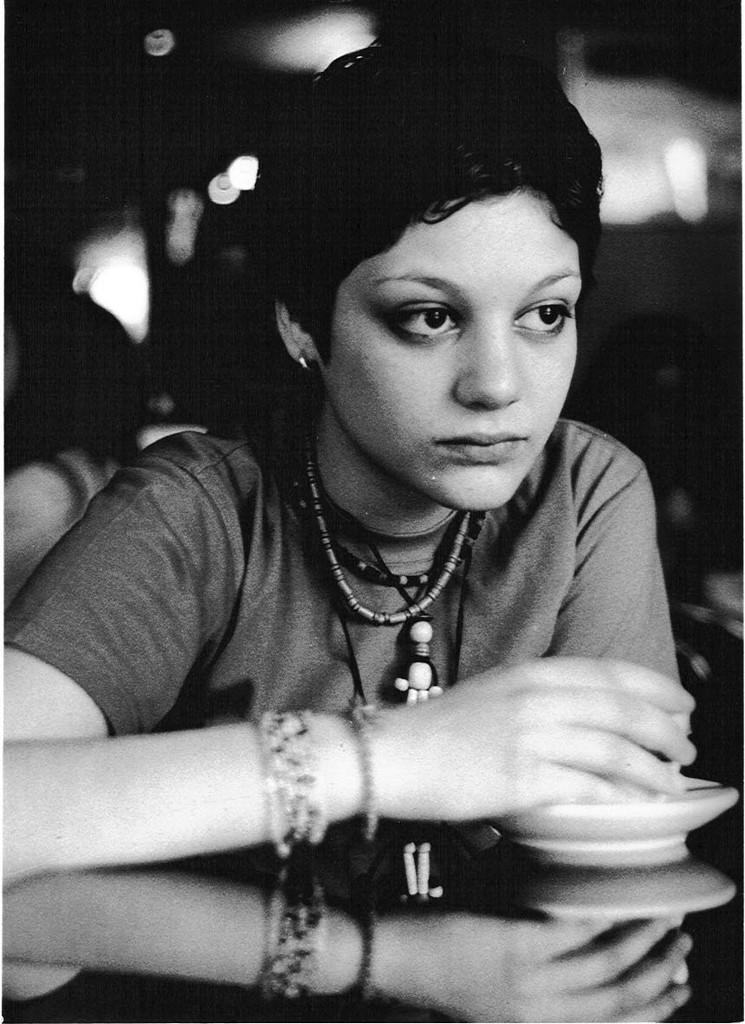Who or what is the main subject in the image? There is a person in the image. What is the person doing in the image? The person is sitting on a table. What is the person holding in his hand? The person is holding a cup and saucer in his hand. What type of straw is the person using to make a statement in the image? There is no straw or statement being made in the image; the person is simply sitting on a table holding a cup and saucer. 